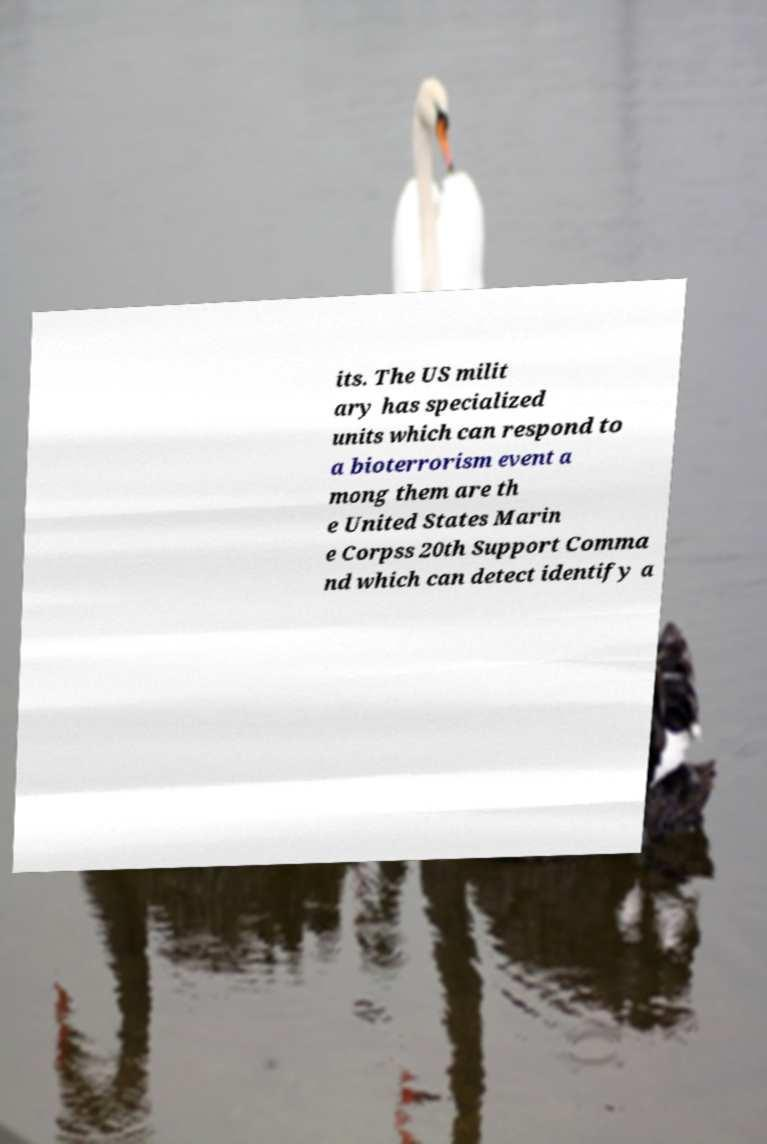Please identify and transcribe the text found in this image. its. The US milit ary has specialized units which can respond to a bioterrorism event a mong them are th e United States Marin e Corpss 20th Support Comma nd which can detect identify a 